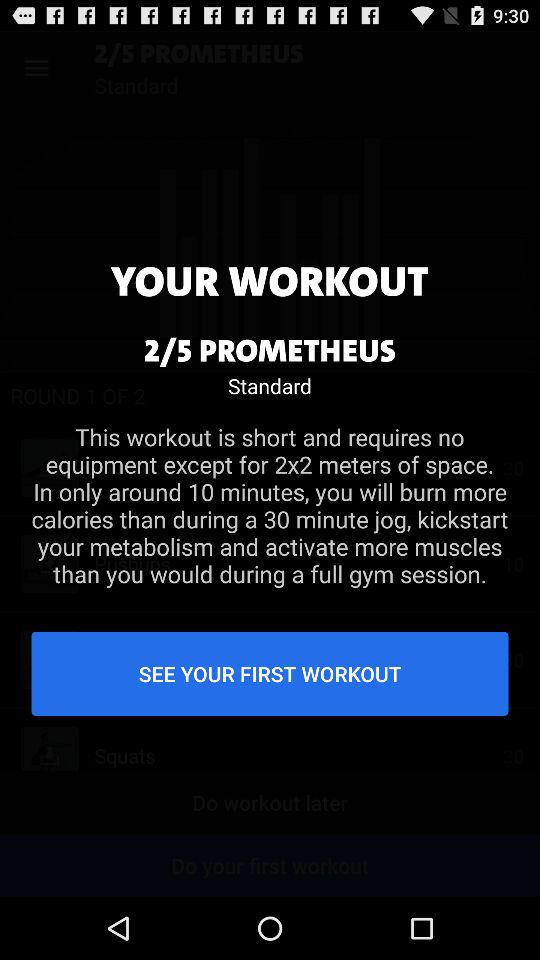How much space is required for the workout? The space required for the workout is 2x2 meters. 